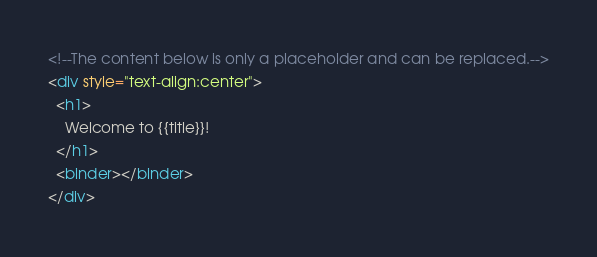<code> <loc_0><loc_0><loc_500><loc_500><_HTML_><!--The content below is only a placeholder and can be replaced.-->
<div style="text-align:center">
  <h1>
    Welcome to {{title}}!
  </h1>
  <binder></binder>
</div>

</code> 